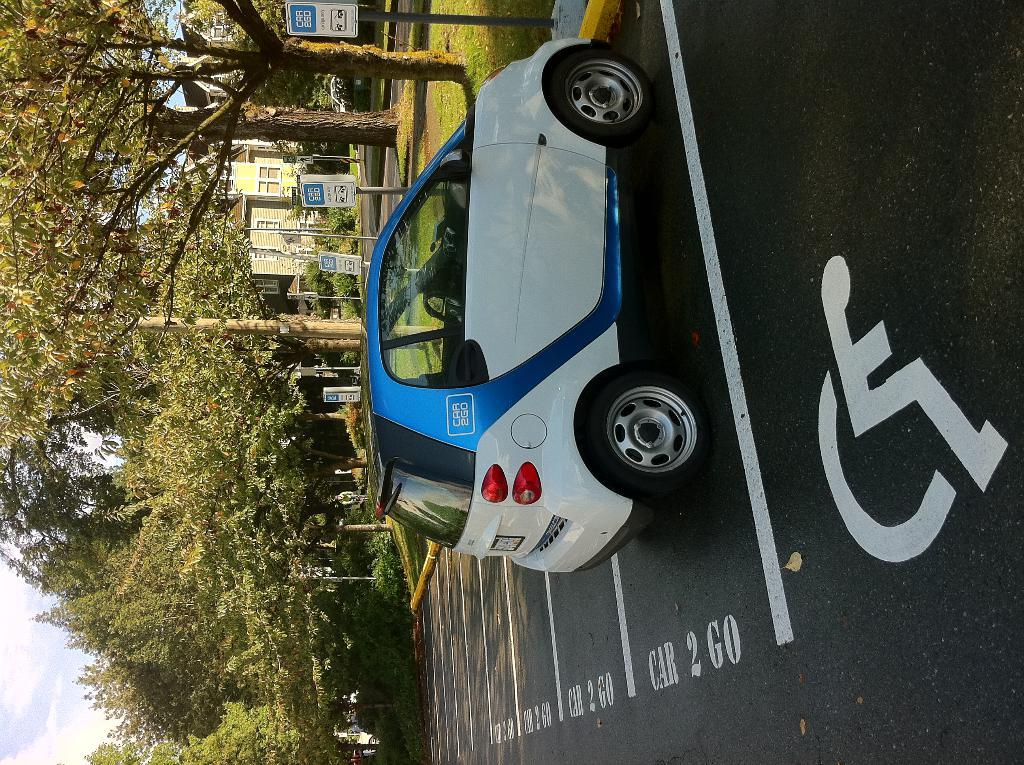What is the main feature of the image? There is a road in the image. What can be seen on the road? A car is parked on the road. What type of vegetation is visible in the image? There are trees visible in the image. What type of structure is present in the image? There is a building in the image. What is visible above the road and the building? The sky is visible in the image. What is the price of the car in the image? The price of the car cannot be determined from the image, as it does not provide any information about the car's make, model, or condition. 